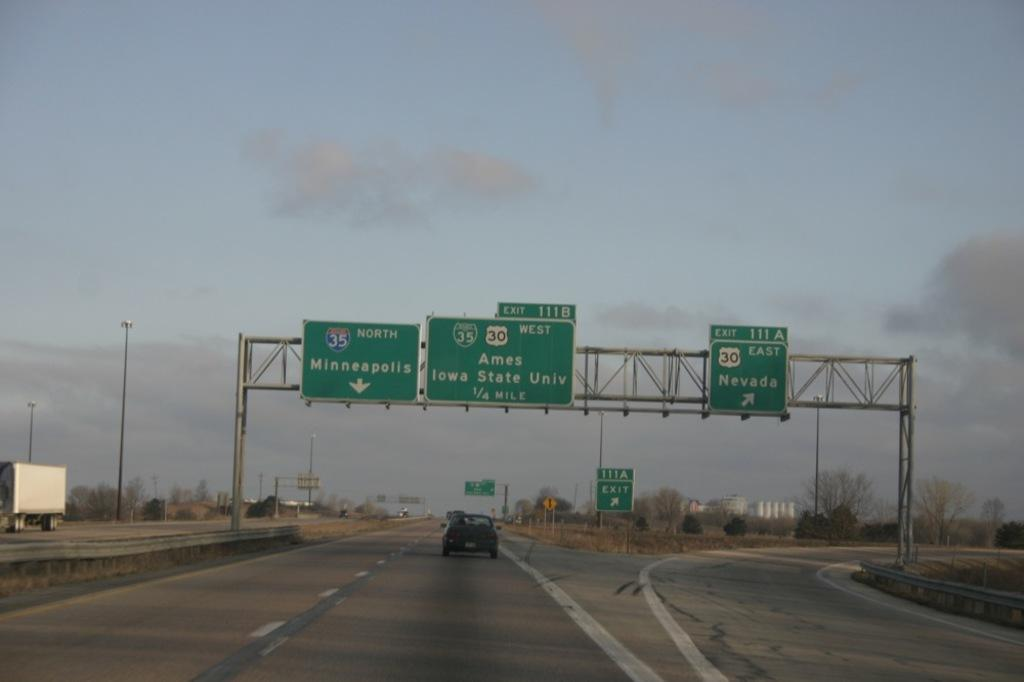<image>
Present a compact description of the photo's key features. A green highway sign points towards Minneapollis and Nevada 